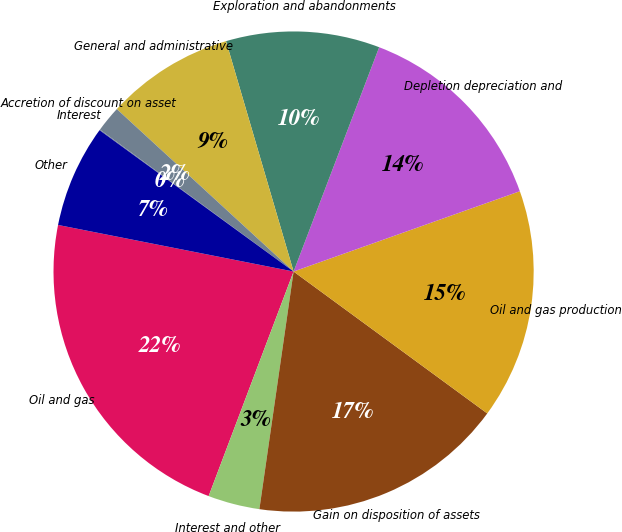<chart> <loc_0><loc_0><loc_500><loc_500><pie_chart><fcel>Oil and gas<fcel>Interest and other<fcel>Gain on disposition of assets<fcel>Oil and gas production<fcel>Depletion depreciation and<fcel>Exploration and abandonments<fcel>General and administrative<fcel>Accretion of discount on asset<fcel>Interest<fcel>Other<nl><fcel>22.35%<fcel>3.48%<fcel>17.21%<fcel>15.49%<fcel>13.77%<fcel>10.34%<fcel>8.63%<fcel>1.76%<fcel>0.05%<fcel>6.91%<nl></chart> 